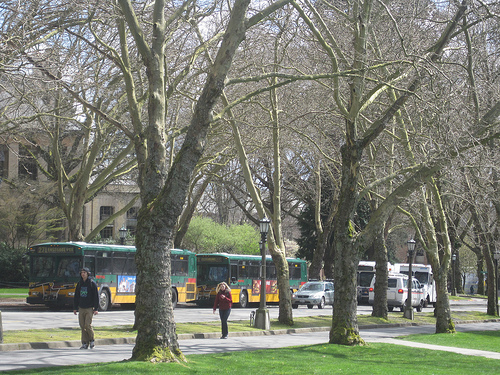How many people are on the sidewalk? 2 